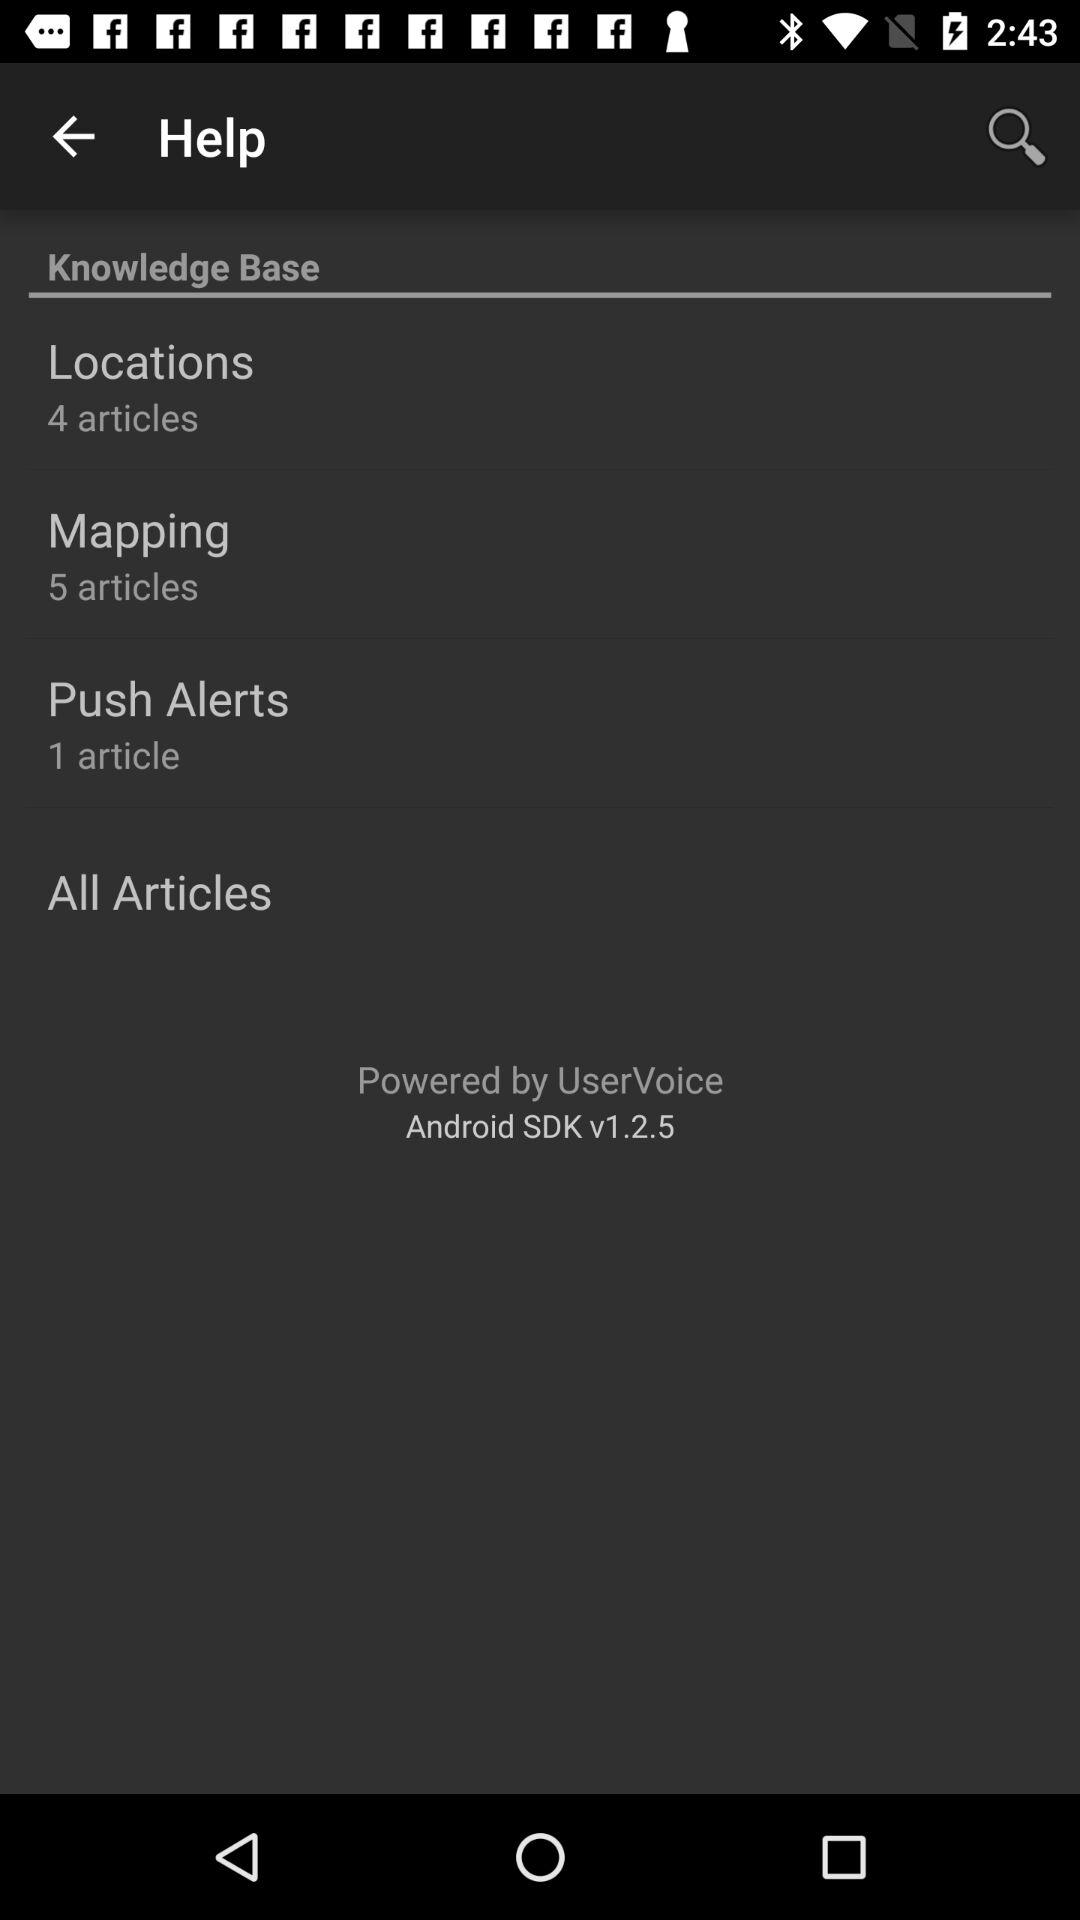How many articles are there in total in the knowledge base?
Answer the question using a single word or phrase. 10 